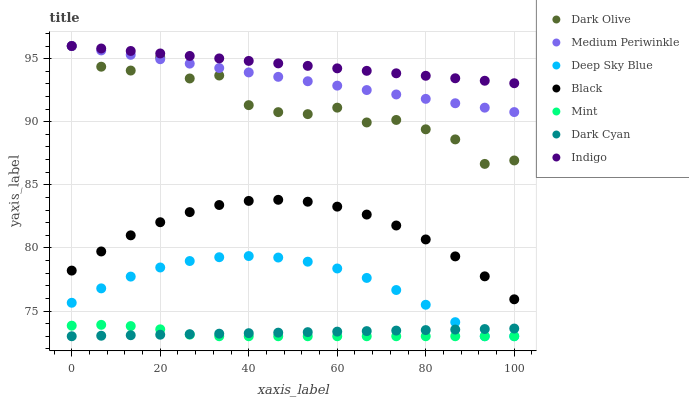Does Mint have the minimum area under the curve?
Answer yes or no. Yes. Does Indigo have the maximum area under the curve?
Answer yes or no. Yes. Does Dark Olive have the minimum area under the curve?
Answer yes or no. No. Does Dark Olive have the maximum area under the curve?
Answer yes or no. No. Is Dark Cyan the smoothest?
Answer yes or no. Yes. Is Dark Olive the roughest?
Answer yes or no. Yes. Is Medium Periwinkle the smoothest?
Answer yes or no. No. Is Medium Periwinkle the roughest?
Answer yes or no. No. Does Deep Sky Blue have the lowest value?
Answer yes or no. Yes. Does Dark Olive have the lowest value?
Answer yes or no. No. Does Medium Periwinkle have the highest value?
Answer yes or no. Yes. Does Black have the highest value?
Answer yes or no. No. Is Deep Sky Blue less than Black?
Answer yes or no. Yes. Is Indigo greater than Mint?
Answer yes or no. Yes. Does Mint intersect Deep Sky Blue?
Answer yes or no. Yes. Is Mint less than Deep Sky Blue?
Answer yes or no. No. Is Mint greater than Deep Sky Blue?
Answer yes or no. No. Does Deep Sky Blue intersect Black?
Answer yes or no. No. 